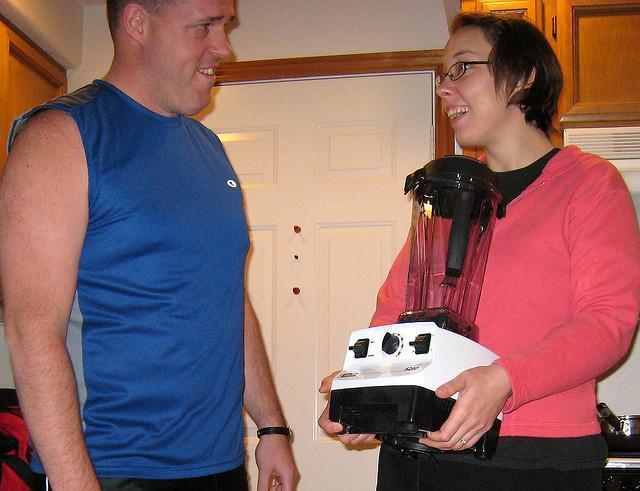How many men are wearing glasses?
Give a very brief answer. 0. How many people are in the photo?
Give a very brief answer. 2. How many dogs are wearing a leash?
Give a very brief answer. 0. 